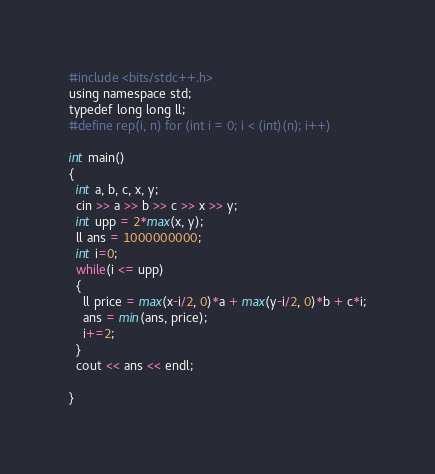Convert code to text. <code><loc_0><loc_0><loc_500><loc_500><_Python_>#include <bits/stdc++.h>
using namespace std;
typedef long long ll;
#define rep(i, n) for (int i = 0; i < (int)(n); i++)

int main()
{
  int a, b, c, x, y;
  cin >> a >> b >> c >> x >> y;
  int upp = 2*max(x, y);
  ll ans = 1000000000;
  int i=0;
  while(i <= upp)
  {
    ll price = max(x-i/2, 0)*a + max(y-i/2, 0)*b + c*i;
    ans = min(ans, price);
    i+=2;
  }
  cout << ans << endl;
  
}
</code> 